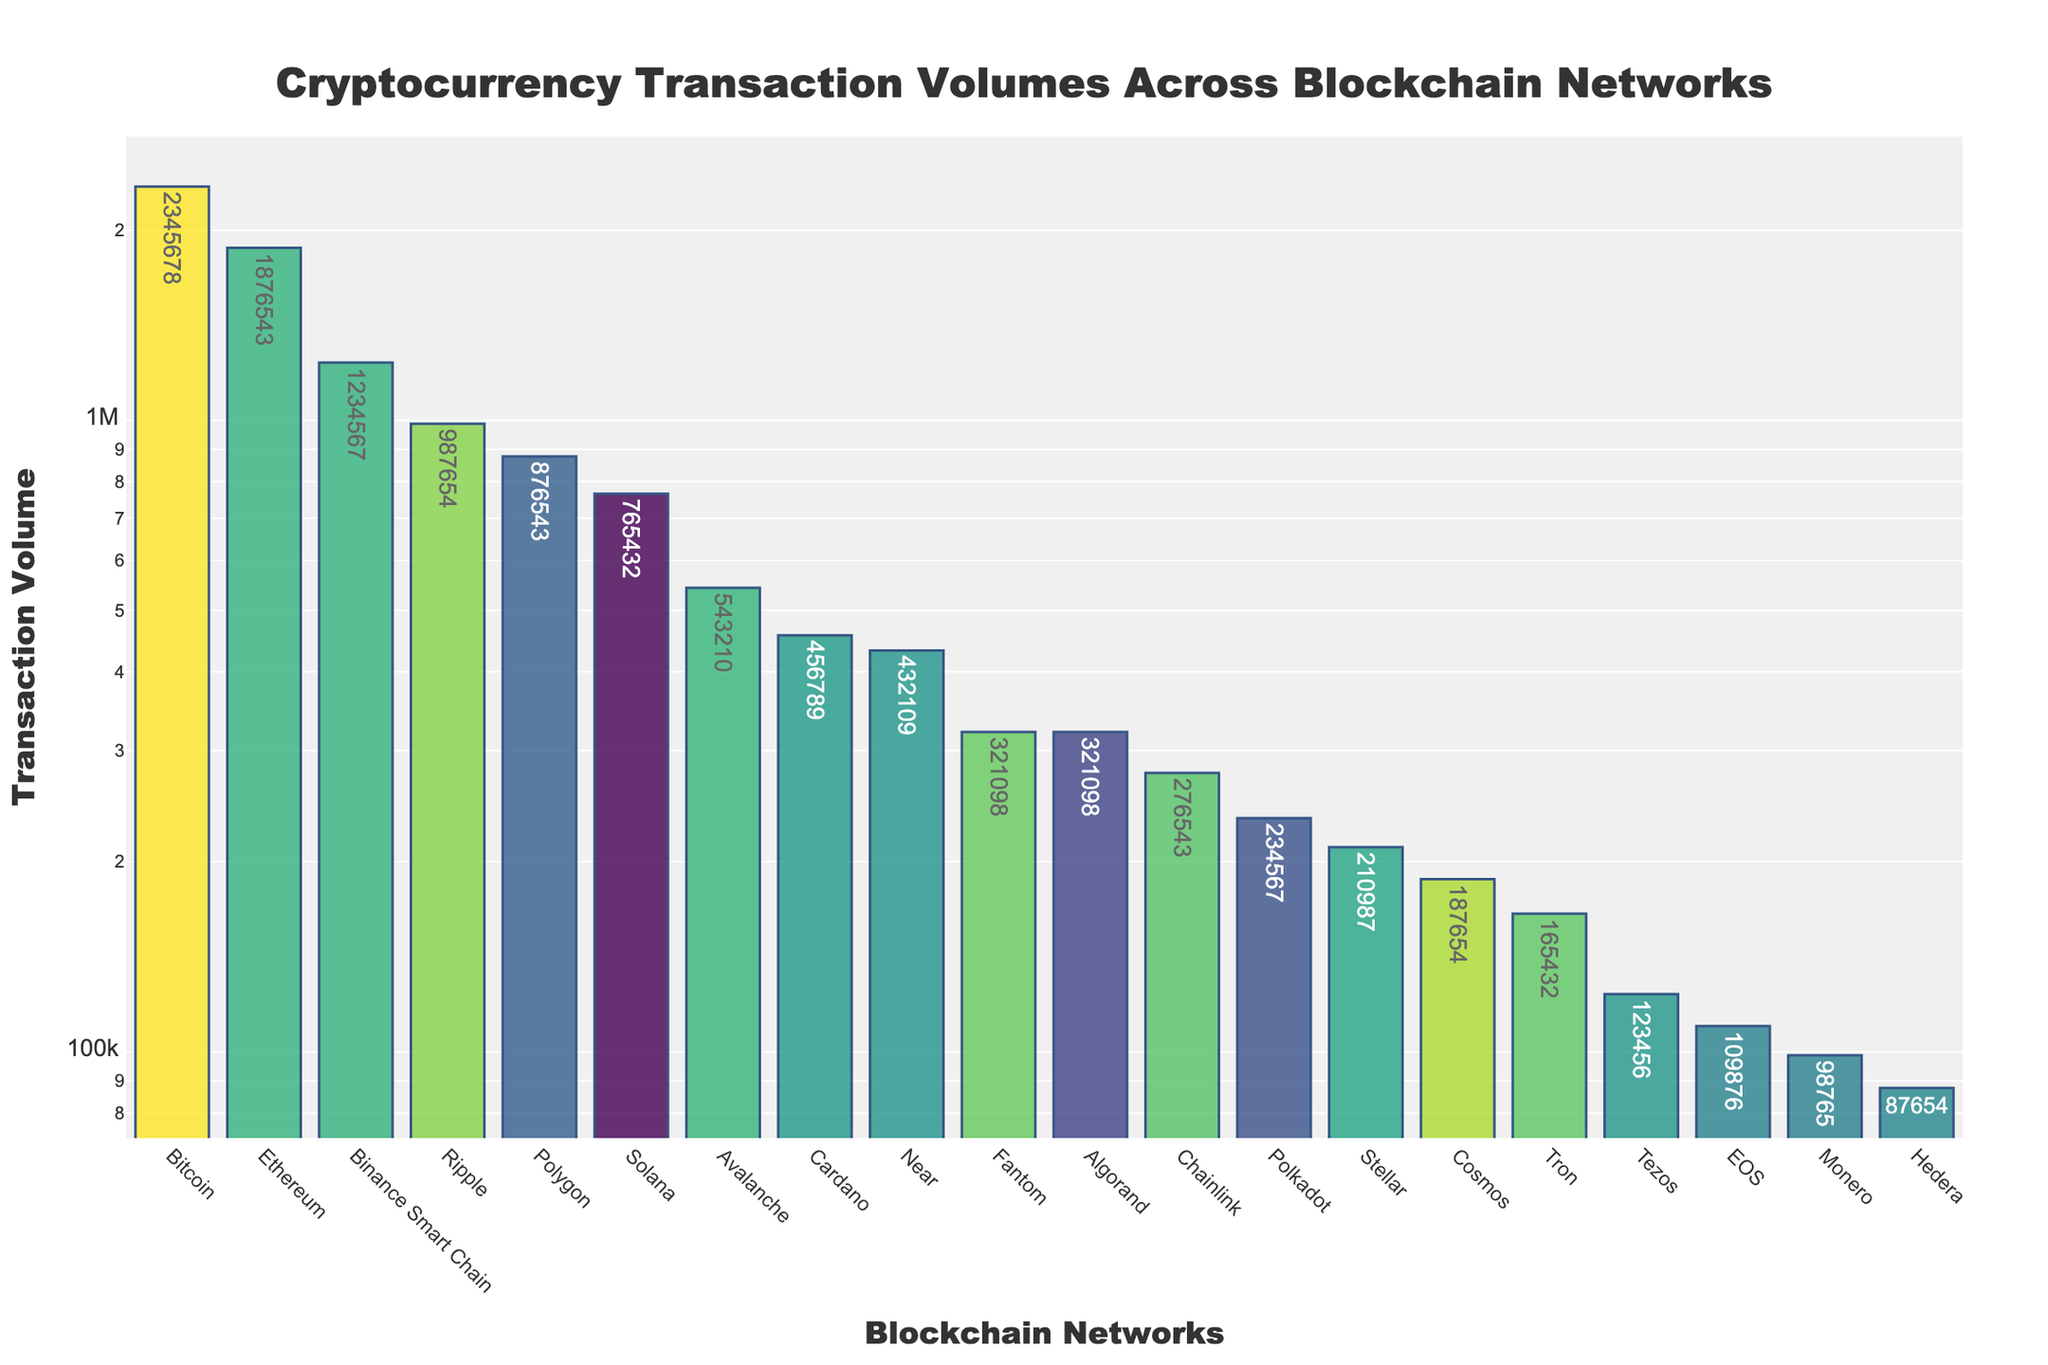What is the title of the plot? The title is generally positioned at the top of the figure and is written in a larger, bold font for emphasis. It summarizes the content of the plot.
Answer: Cryptocurrency Transaction Volumes Across Blockchain Networks Which Blockchain network has the highest transaction volume? By scanning the length of the bars, the tallest bar represents the network with the highest transaction volume.
Answer: Bitcoin How many blockchain networks are represented in the plot? Count the number of bars in the plot to determine the number of blockchain networks.
Answer: 20 Which blockchain network has the lowest transaction volume? Look for the shortest bar in the plot which indicates the smallest transaction volume.
Answer: Hedera What is the total transaction volume of Bitcoin and Ethereum combined? Add the transaction volumes of the Bitcoin and Ethereum bars. Bitcoin volume is 2,345,678 and Ethereum is 1,876,543. So, 2,345,678 + 1,876,543 = 4,222,221.
Answer: 4,222,221 What is the median transaction volume among all blockchain networks? Sort the blockchain networks by transaction volume, then find the middle value. For 20 data points, the median is the average of the 10th and 11th values when sorted. These are Stellar (210,987) and Chainlink (276,543), so the median is (210,987 + 276,543) / 2 = 243,765.
Answer: 243,765 Compare the transaction volume of Binance Smart Chain and Algorand. Which one is greater and by how much? Look at the height of the bars for Binance Smart Chain and Algorand and subtract the smaller volume from the larger one. Binance Smart Chain is 1,234,567 and Algorand is 321,098. Thus, 1,234,567 - 321,098 = 913,469.
Answer: Binance Smart Chain is greater by 913,469 What percentage of the total transaction volume does Bitcoin represent? Sum all transaction volumes to get the total, then divide Bitcoin's volume by this total and multiply by 100 for the percentage. Total volume = 14,583,439, Bitcoin volume = 2,345,678. Percentage = (2,345,678 / 14,583,439) * 100 ≈ 16.09%.
Answer: 16.09% Which three blockchain networks have the middle-highest transaction volumes (rank 8th, 9th, and 10th highest)? Sort the transaction volumes in descending order and identify the 8th, 9th, and 10th values. These are Polkadot (234,567), Near (432,109), and Tezos (123,456) respectively.
Answer: Polkadot, Near, Tezos What is the average transaction volume across all blockchain networks? Add up all transaction volumes and divide by the total number of networks (20). The sum is 14,583,439 and dividing by 20 yields an average of 729,171.95.
Answer: 729,171.95 